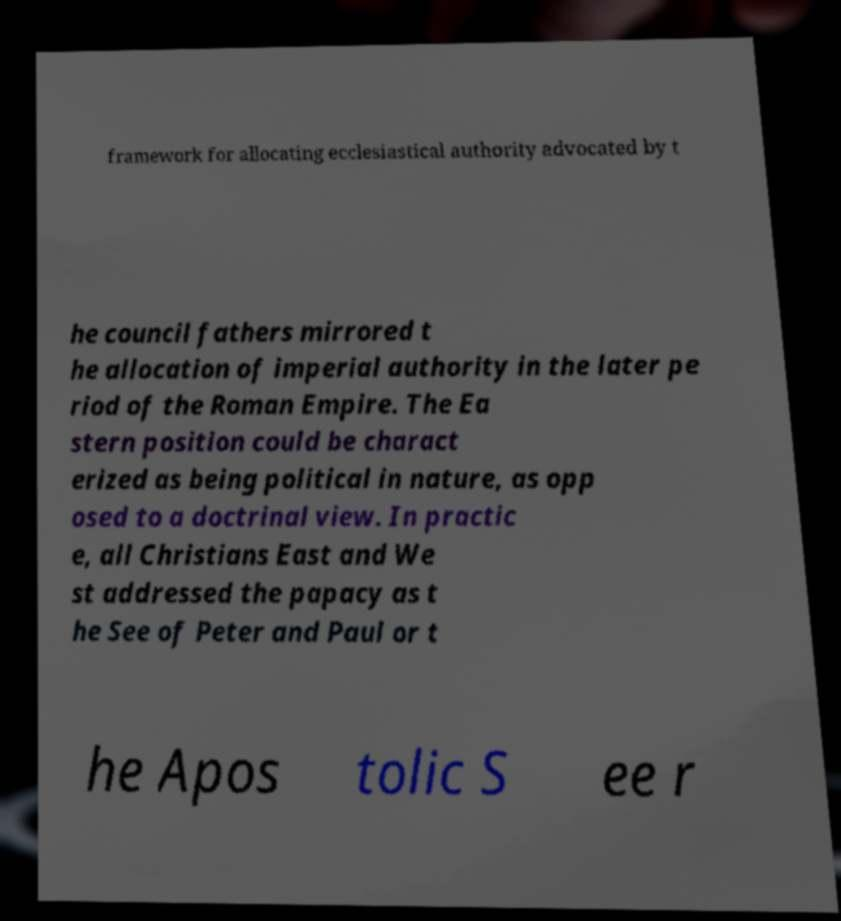Can you read and provide the text displayed in the image?This photo seems to have some interesting text. Can you extract and type it out for me? framework for allocating ecclesiastical authority advocated by t he council fathers mirrored t he allocation of imperial authority in the later pe riod of the Roman Empire. The Ea stern position could be charact erized as being political in nature, as opp osed to a doctrinal view. In practic e, all Christians East and We st addressed the papacy as t he See of Peter and Paul or t he Apos tolic S ee r 